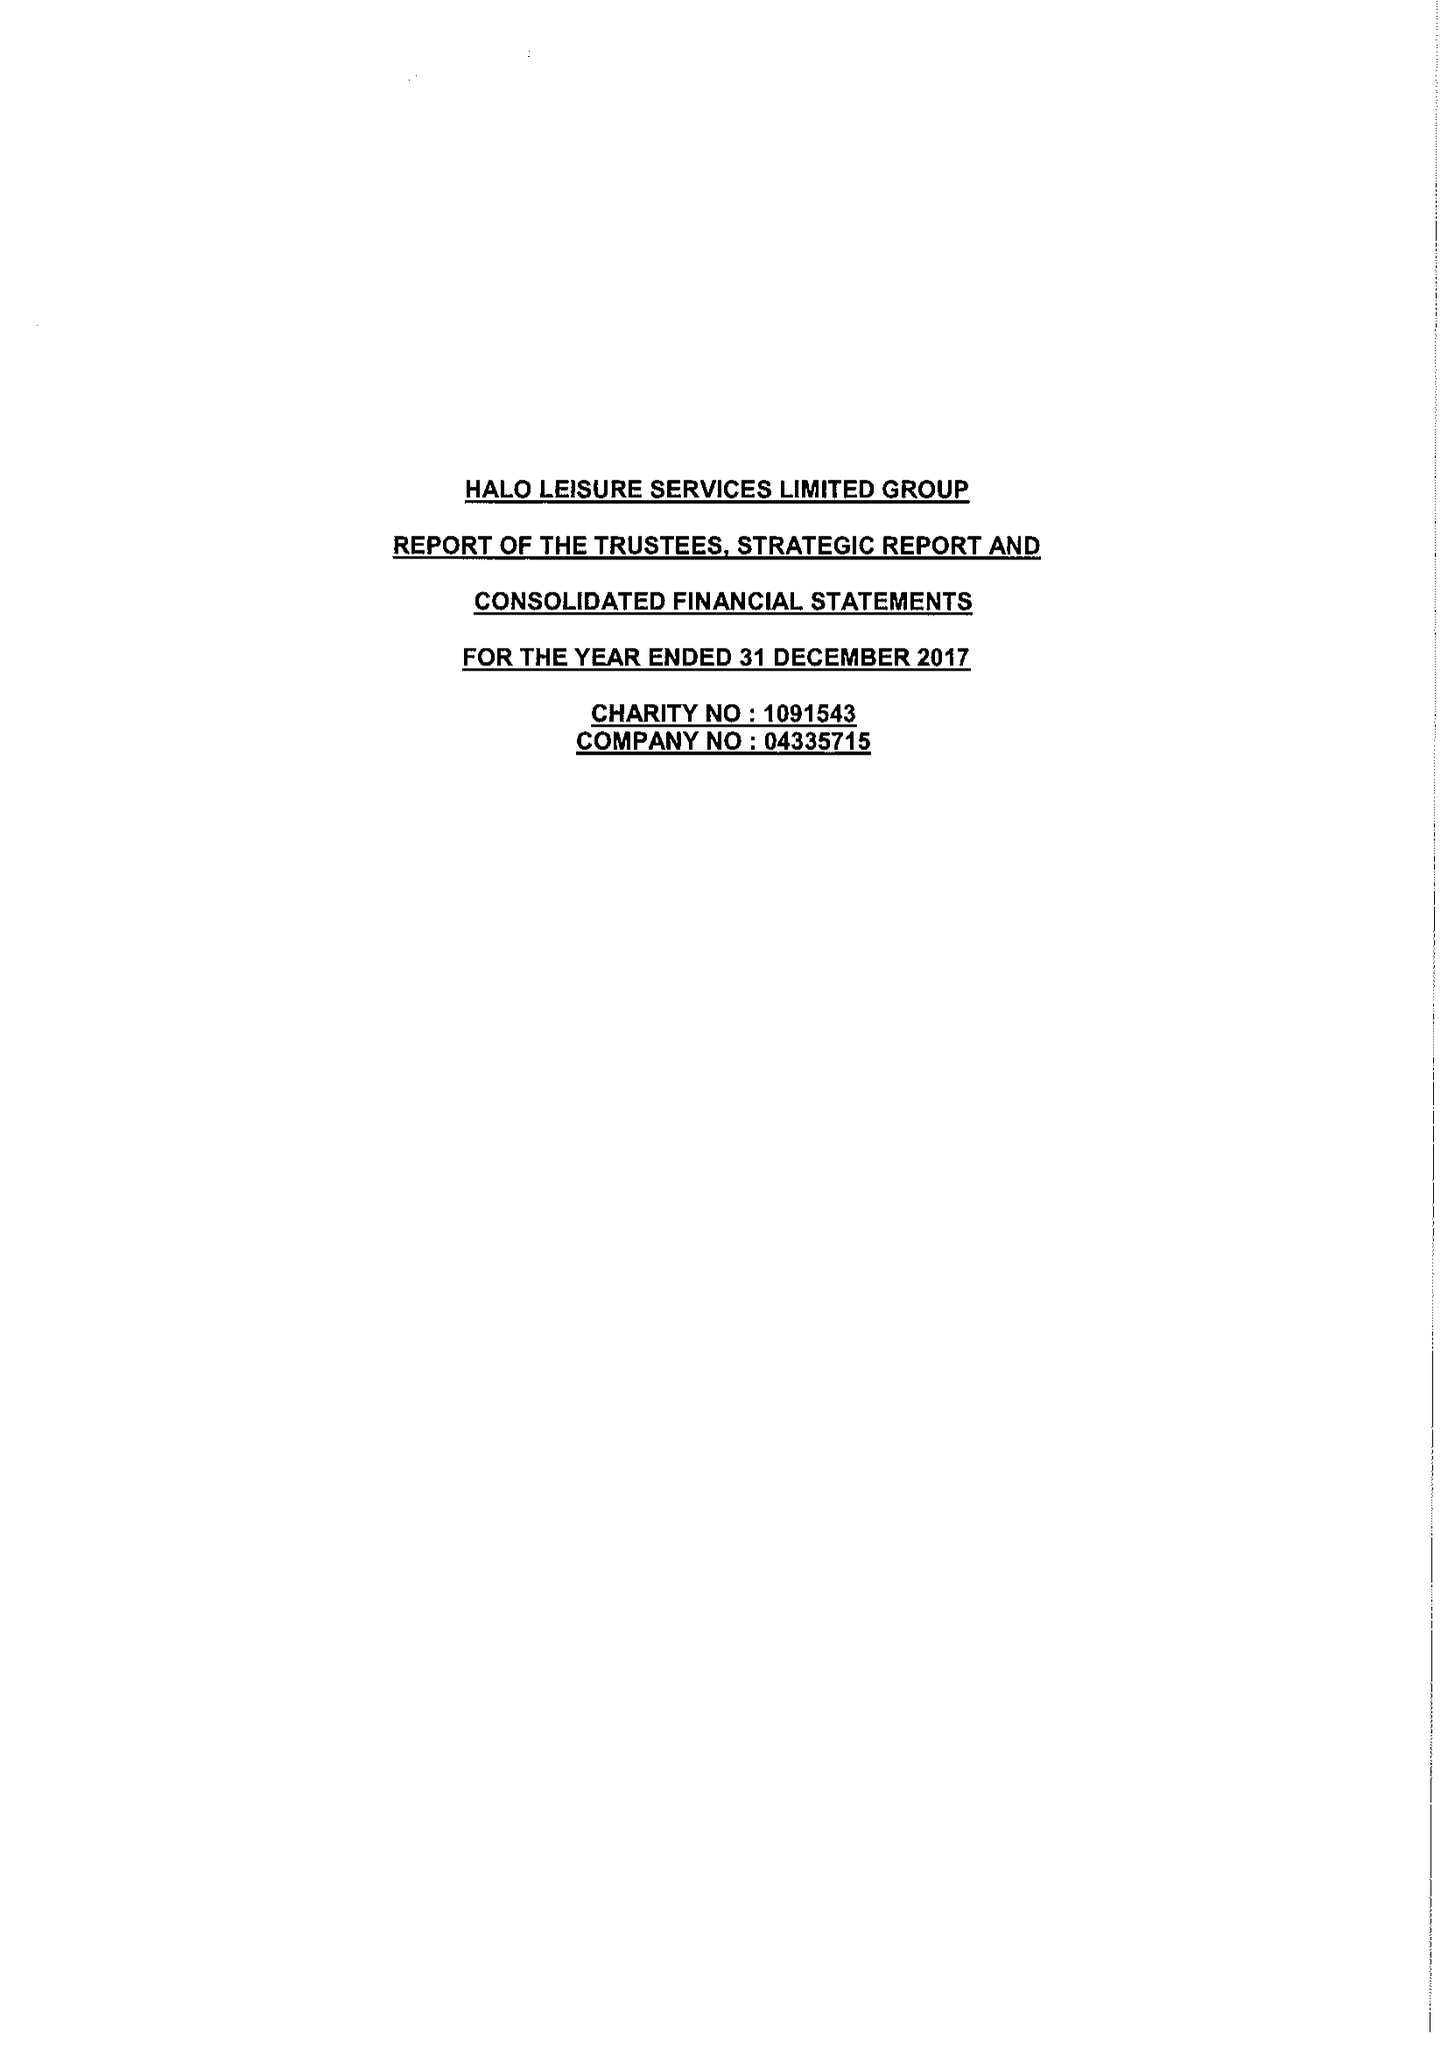What is the value for the spending_annually_in_british_pounds?
Answer the question using a single word or phrase. 15151920.00 